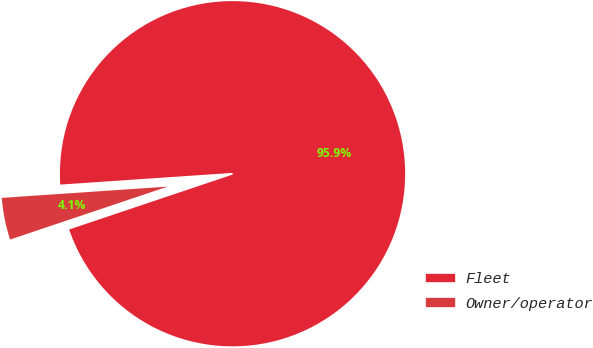<chart> <loc_0><loc_0><loc_500><loc_500><pie_chart><fcel>Fleet<fcel>Owner/operator<nl><fcel>95.92%<fcel>4.08%<nl></chart> 